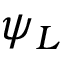<formula> <loc_0><loc_0><loc_500><loc_500>\psi _ { L }</formula> 